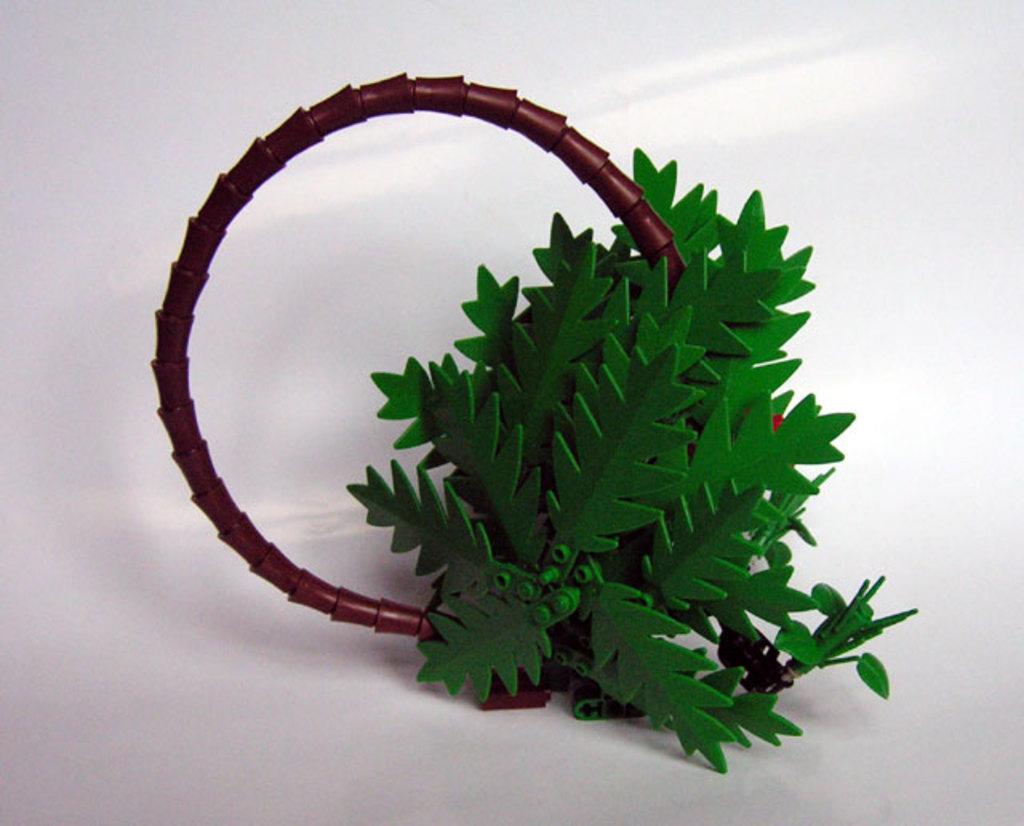In one or two sentences, can you explain what this image depicts? In this picture we can see leaves and some objects on a white surface. 